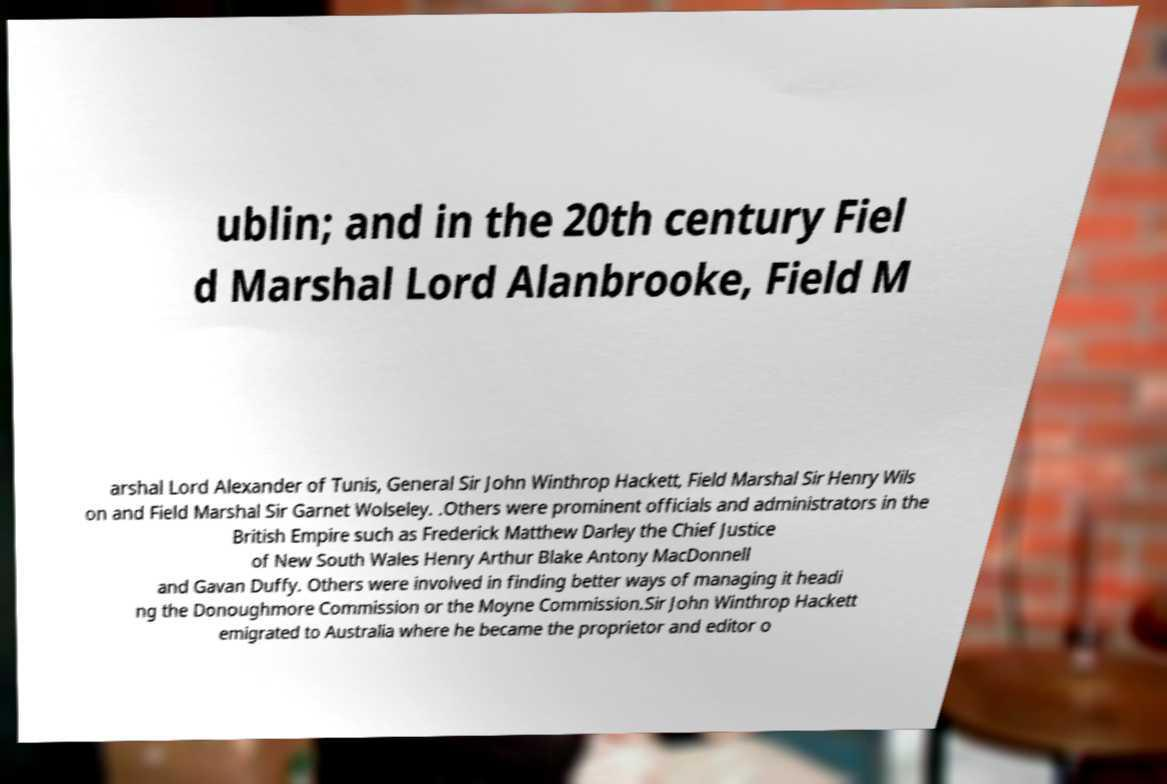Could you extract and type out the text from this image? ublin; and in the 20th century Fiel d Marshal Lord Alanbrooke, Field M arshal Lord Alexander of Tunis, General Sir John Winthrop Hackett, Field Marshal Sir Henry Wils on and Field Marshal Sir Garnet Wolseley. .Others were prominent officials and administrators in the British Empire such as Frederick Matthew Darley the Chief Justice of New South Wales Henry Arthur Blake Antony MacDonnell and Gavan Duffy. Others were involved in finding better ways of managing it headi ng the Donoughmore Commission or the Moyne Commission.Sir John Winthrop Hackett emigrated to Australia where he became the proprietor and editor o 